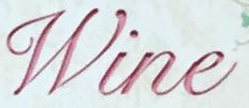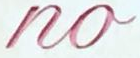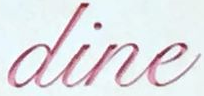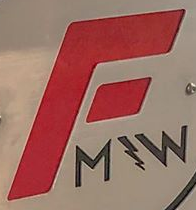Read the text content from these images in order, separated by a semicolon. Wine; no; dine; F 